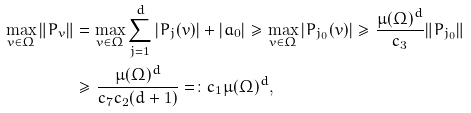<formula> <loc_0><loc_0><loc_500><loc_500>\max _ { v \in \Omega } \| P _ { v } \| & = \max _ { v \in \Omega } \sum _ { j = 1 } ^ { d } | P _ { j } ( v ) | + | a _ { 0 } | \geq \max _ { v \in \Omega } | P _ { j _ { 0 } } ( v ) | \geq \frac { \mu ( \Omega ) ^ { d } } { c _ { 3 } } \| P _ { j _ { 0 } } \| \\ & \geq \frac { \mu ( \Omega ) ^ { d } } { c _ { 7 } c _ { 2 } ( d + 1 ) } = \colon c _ { 1 } \mu ( \Omega ) ^ { d } ,</formula> 